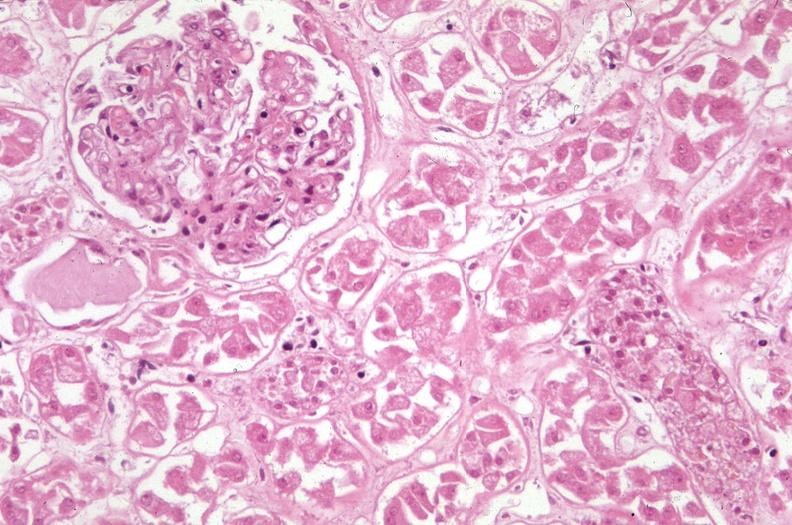how many antitrypsin does this image show kidney, acute tubular necrosis due to coagulopathy, disseminated intravascular coagulation dic, and shock, alpha-deficiency?
Answer the question using a single word or phrase. 1 